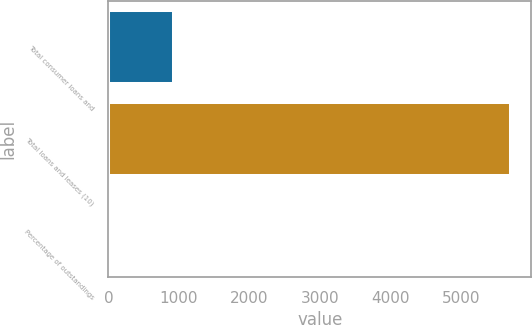Convert chart to OTSL. <chart><loc_0><loc_0><loc_500><loc_500><bar_chart><fcel>Total consumer loans and<fcel>Total loans and leases (10)<fcel>Percentage of outstandings<nl><fcel>928<fcel>5710<fcel>0.61<nl></chart> 